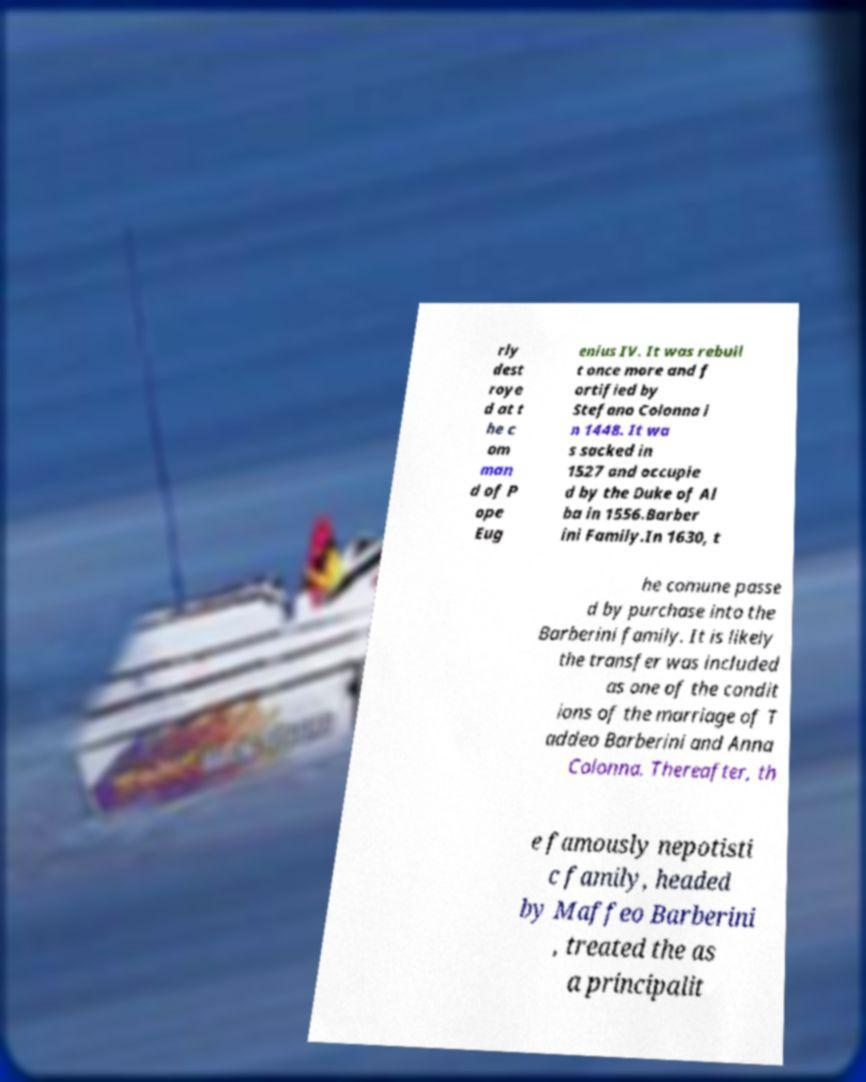Can you accurately transcribe the text from the provided image for me? rly dest roye d at t he c om man d of P ope Eug enius IV. It was rebuil t once more and f ortified by Stefano Colonna i n 1448. It wa s sacked in 1527 and occupie d by the Duke of Al ba in 1556.Barber ini Family.In 1630, t he comune passe d by purchase into the Barberini family. It is likely the transfer was included as one of the condit ions of the marriage of T addeo Barberini and Anna Colonna. Thereafter, th e famously nepotisti c family, headed by Maffeo Barberini , treated the as a principalit 